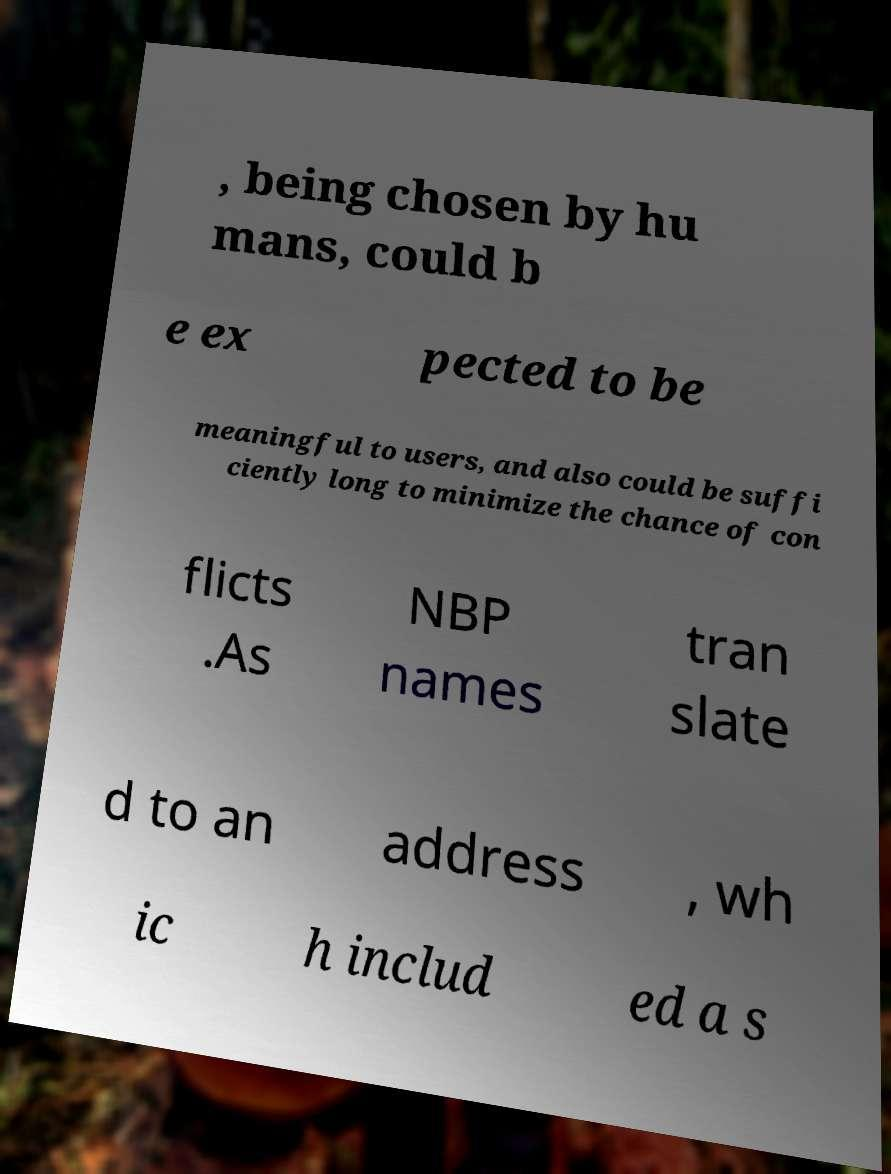There's text embedded in this image that I need extracted. Can you transcribe it verbatim? , being chosen by hu mans, could b e ex pected to be meaningful to users, and also could be suffi ciently long to minimize the chance of con flicts .As NBP names tran slate d to an address , wh ic h includ ed a s 